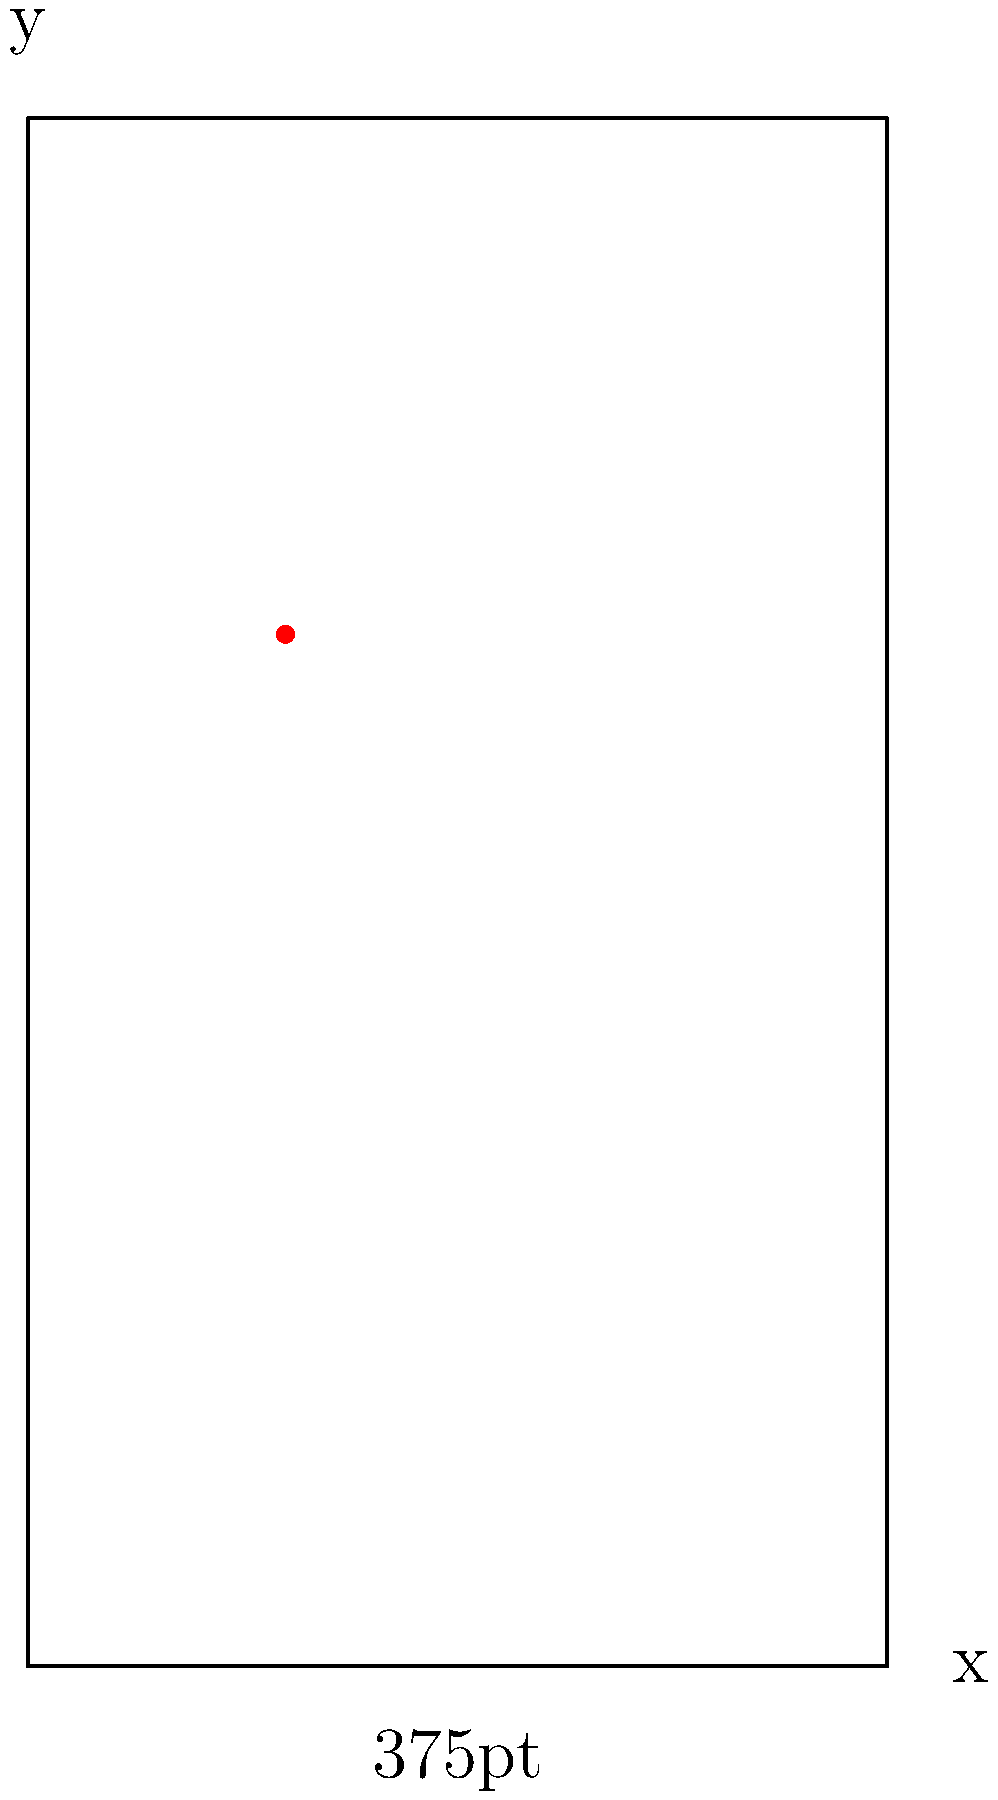An iOS app is being tested on an iPhone 8 with a screen resolution of 375x667 points. A touch event is registered at the coordinates (112.5, 400) in the app's coordinate system. If the app needs to be scaled for an iPhone 12 Pro Max with a screen resolution of 428x926 points, what would be the corresponding touch coordinates on this larger device? To solve this problem, we need to follow these steps:

1. Understand the given information:
   - iPhone 8 resolution: 375 x 667 points
   - iPhone 12 Pro Max resolution: 428 x 926 points
   - Original touch coordinates: (112.5, 400)

2. Calculate the scaling factors for both dimensions:
   - X-axis scaling factor: $\frac{428}{375} = 1.1413$
   - Y-axis scaling factor: $\frac{926}{667} = 1.3883$

3. Apply the scaling factors to the original coordinates:
   - New X coordinate: $112.5 \times 1.1413 = 128.39625$
   - New Y coordinate: $400 \times 1.3883 = 555.32$

4. Round the results to two decimal places for practical use:
   - Final X coordinate: 128.40
   - Final Y coordinate: 555.32

Therefore, the corresponding touch coordinates on the iPhone 12 Pro Max would be (128.40, 555.32).
Answer: (128.40, 555.32) 